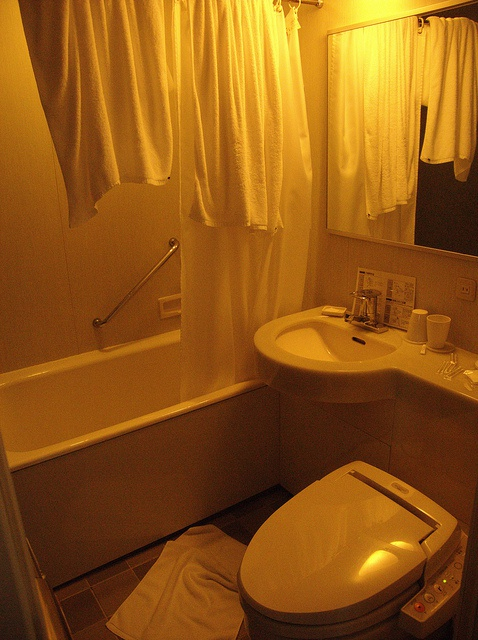Describe the objects in this image and their specific colors. I can see toilet in orange, red, maroon, and black tones, sink in orange and maroon tones, cup in orange, brown, and maroon tones, and cup in orange, brown, and maroon tones in this image. 